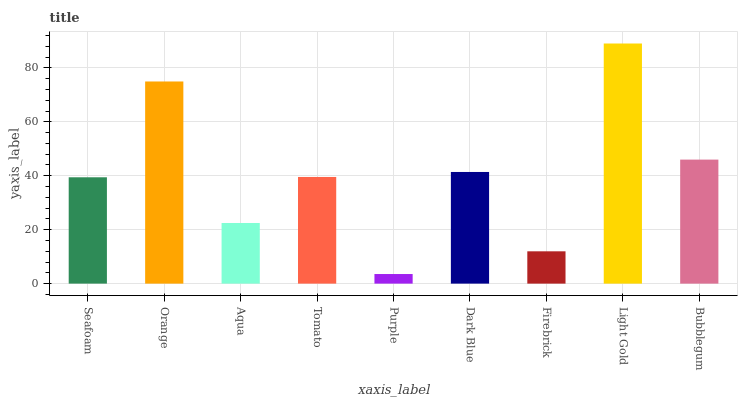Is Purple the minimum?
Answer yes or no. Yes. Is Light Gold the maximum?
Answer yes or no. Yes. Is Orange the minimum?
Answer yes or no. No. Is Orange the maximum?
Answer yes or no. No. Is Orange greater than Seafoam?
Answer yes or no. Yes. Is Seafoam less than Orange?
Answer yes or no. Yes. Is Seafoam greater than Orange?
Answer yes or no. No. Is Orange less than Seafoam?
Answer yes or no. No. Is Tomato the high median?
Answer yes or no. Yes. Is Tomato the low median?
Answer yes or no. Yes. Is Purple the high median?
Answer yes or no. No. Is Purple the low median?
Answer yes or no. No. 